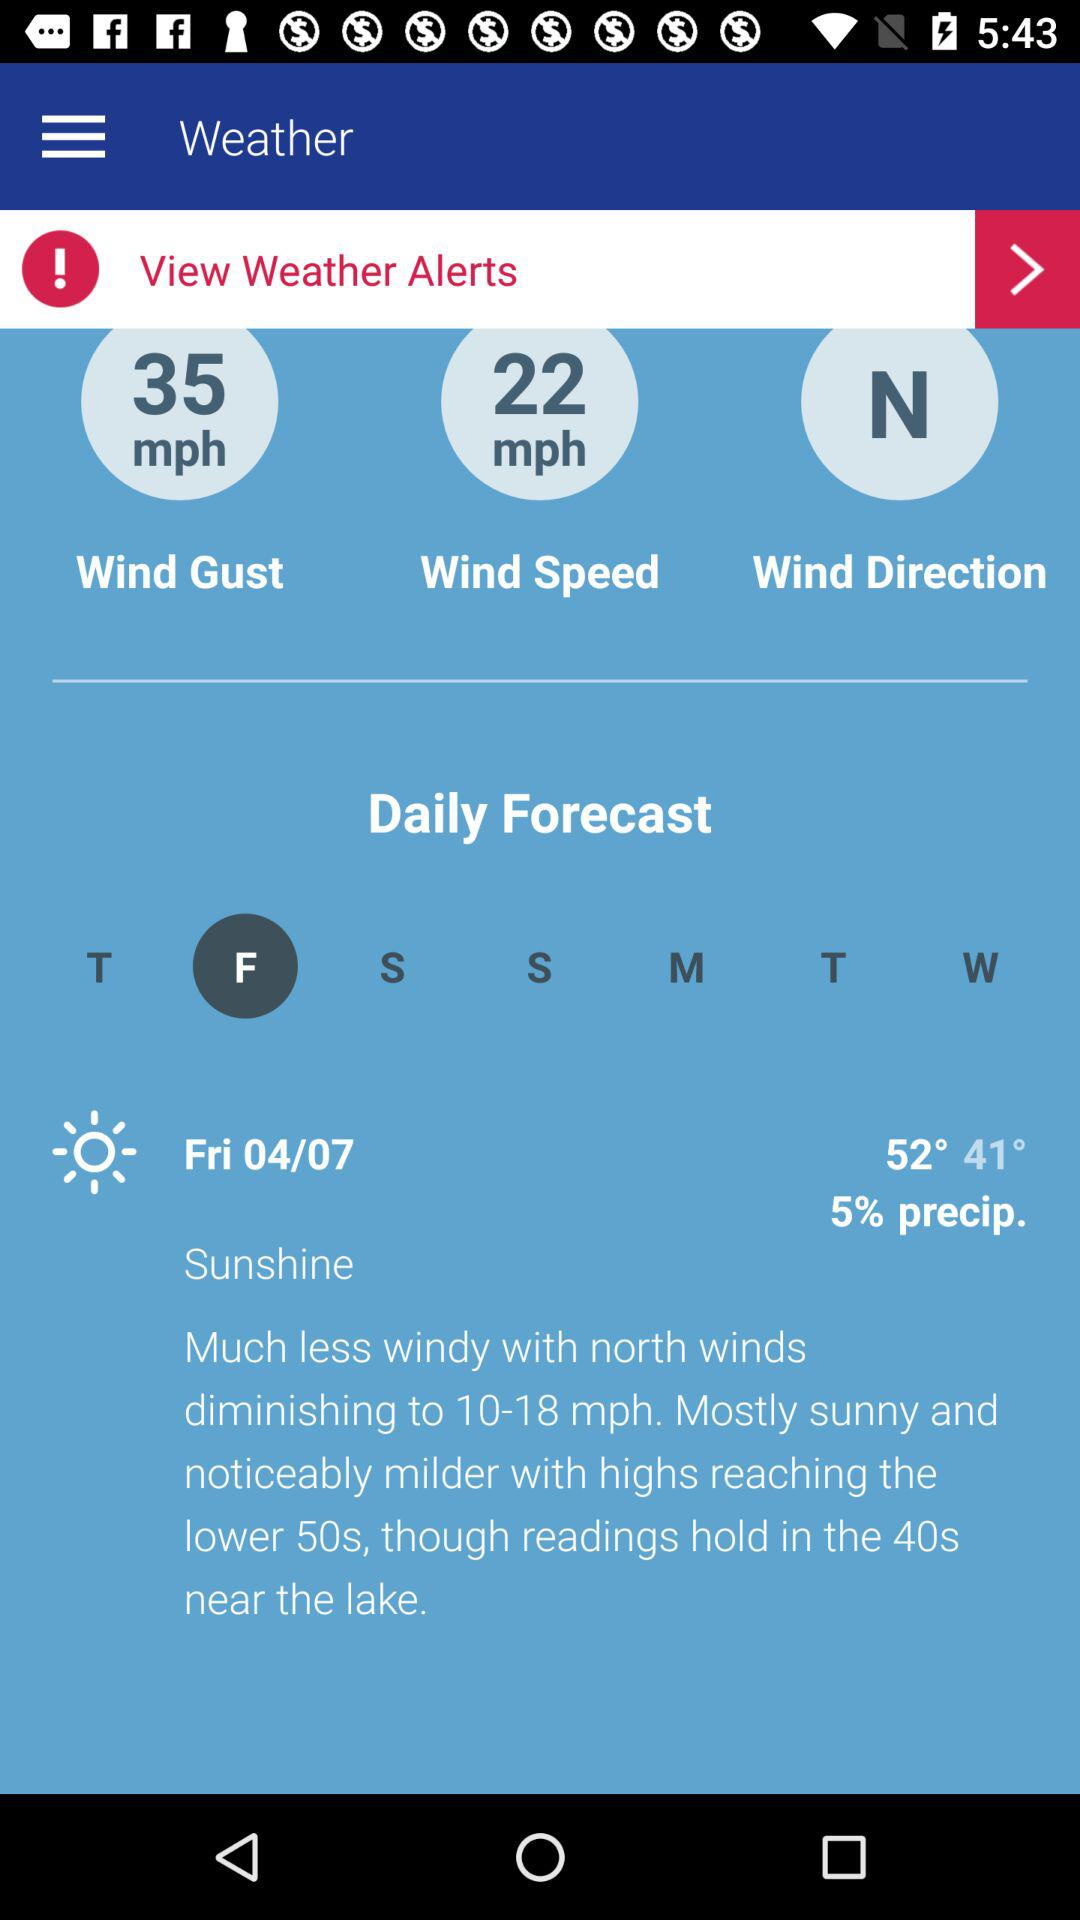What is the application name? The application name is "Weather". 